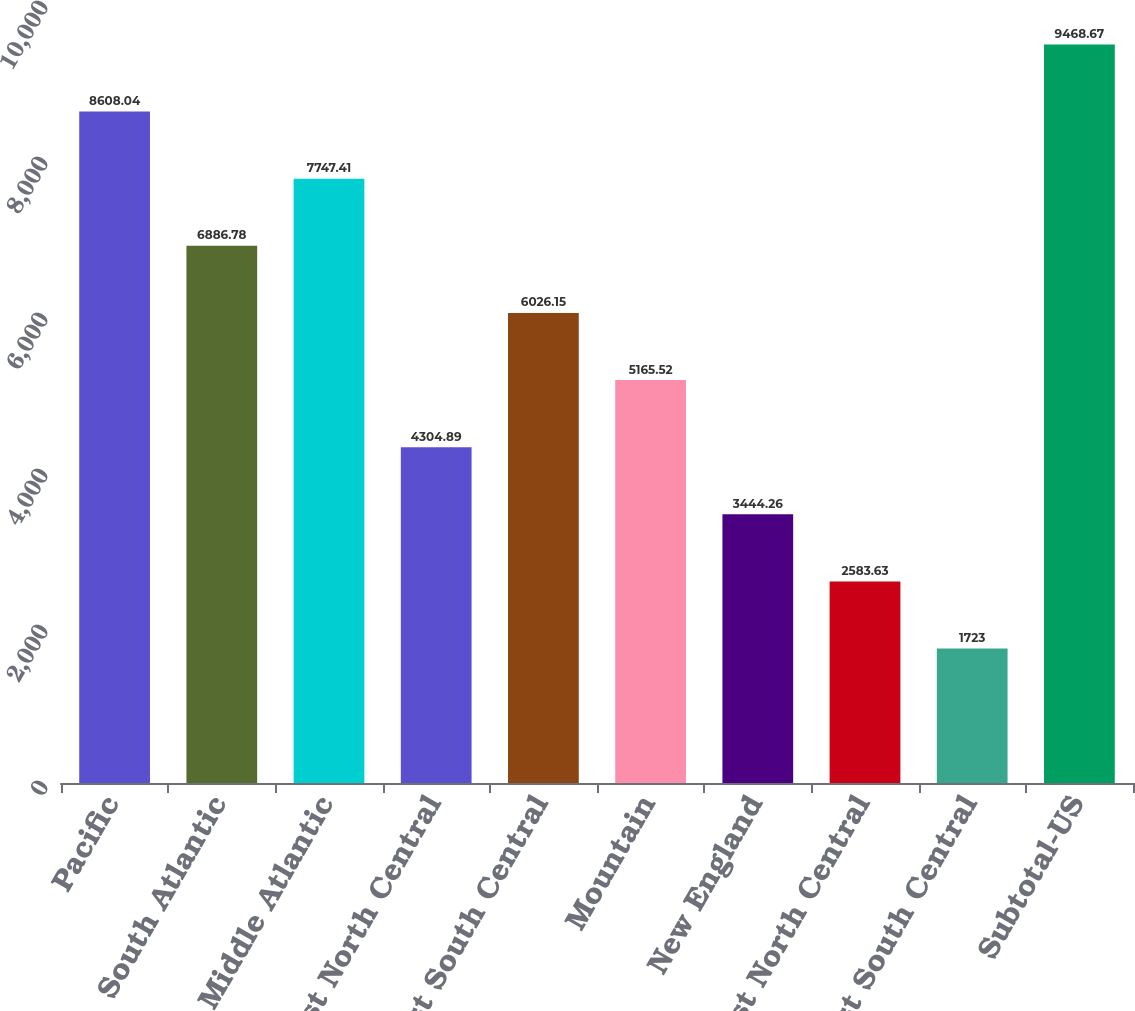Convert chart to OTSL. <chart><loc_0><loc_0><loc_500><loc_500><bar_chart><fcel>Pacific<fcel>South Atlantic<fcel>Middle Atlantic<fcel>East North Central<fcel>West South Central<fcel>Mountain<fcel>New England<fcel>West North Central<fcel>East South Central<fcel>Subtotal-US<nl><fcel>8608.04<fcel>6886.78<fcel>7747.41<fcel>4304.89<fcel>6026.15<fcel>5165.52<fcel>3444.26<fcel>2583.63<fcel>1723<fcel>9468.67<nl></chart> 